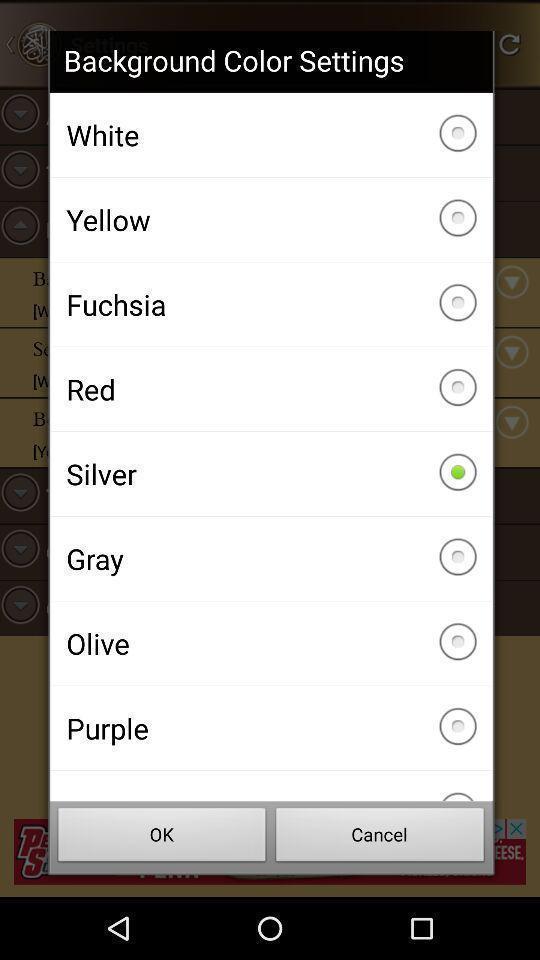What details can you identify in this image? Popup to set the background from list in the app. 